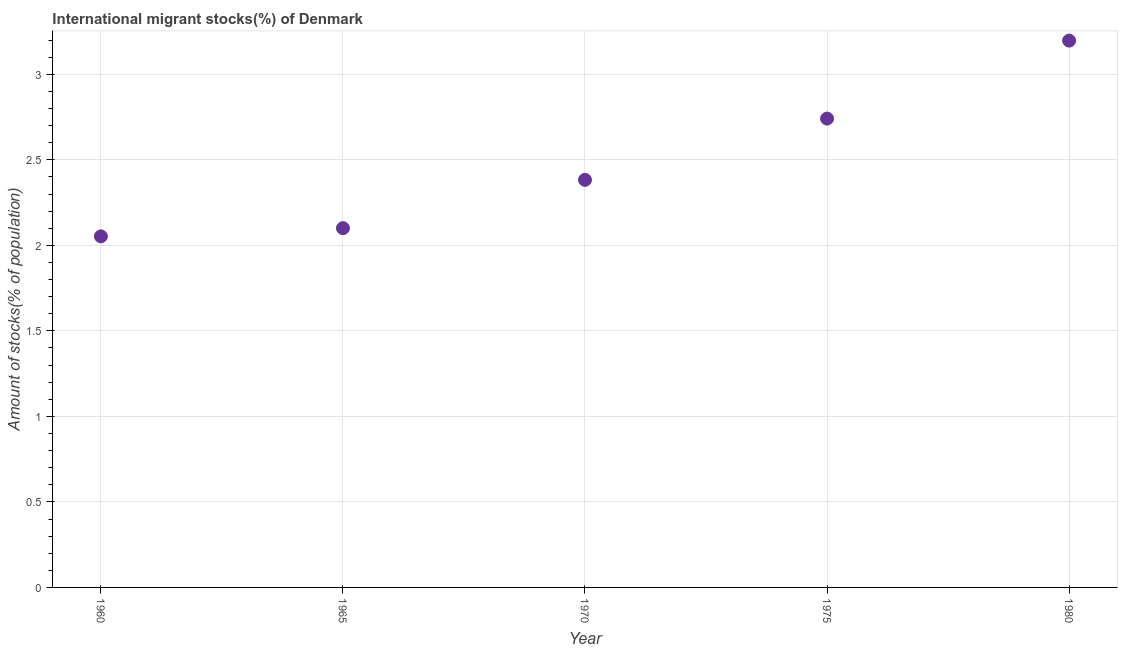What is the number of international migrant stocks in 1975?
Provide a succinct answer. 2.74. Across all years, what is the maximum number of international migrant stocks?
Offer a very short reply. 3.2. Across all years, what is the minimum number of international migrant stocks?
Your answer should be very brief. 2.05. In which year was the number of international migrant stocks maximum?
Your response must be concise. 1980. What is the sum of the number of international migrant stocks?
Your answer should be compact. 12.47. What is the difference between the number of international migrant stocks in 1960 and 1965?
Provide a short and direct response. -0.05. What is the average number of international migrant stocks per year?
Provide a succinct answer. 2.49. What is the median number of international migrant stocks?
Keep it short and to the point. 2.38. In how many years, is the number of international migrant stocks greater than 2 %?
Your answer should be very brief. 5. Do a majority of the years between 1970 and 1960 (inclusive) have number of international migrant stocks greater than 1.1 %?
Make the answer very short. No. What is the ratio of the number of international migrant stocks in 1970 to that in 1975?
Offer a very short reply. 0.87. Is the number of international migrant stocks in 1965 less than that in 1975?
Make the answer very short. Yes. Is the difference between the number of international migrant stocks in 1960 and 1970 greater than the difference between any two years?
Make the answer very short. No. What is the difference between the highest and the second highest number of international migrant stocks?
Provide a succinct answer. 0.46. What is the difference between the highest and the lowest number of international migrant stocks?
Make the answer very short. 1.14. How many dotlines are there?
Offer a very short reply. 1. How many years are there in the graph?
Make the answer very short. 5. What is the difference between two consecutive major ticks on the Y-axis?
Give a very brief answer. 0.5. Does the graph contain any zero values?
Your answer should be very brief. No. What is the title of the graph?
Your answer should be very brief. International migrant stocks(%) of Denmark. What is the label or title of the X-axis?
Offer a terse response. Year. What is the label or title of the Y-axis?
Make the answer very short. Amount of stocks(% of population). What is the Amount of stocks(% of population) in 1960?
Your response must be concise. 2.05. What is the Amount of stocks(% of population) in 1965?
Your response must be concise. 2.1. What is the Amount of stocks(% of population) in 1970?
Keep it short and to the point. 2.38. What is the Amount of stocks(% of population) in 1975?
Offer a very short reply. 2.74. What is the Amount of stocks(% of population) in 1980?
Keep it short and to the point. 3.2. What is the difference between the Amount of stocks(% of population) in 1960 and 1965?
Your answer should be very brief. -0.05. What is the difference between the Amount of stocks(% of population) in 1960 and 1970?
Give a very brief answer. -0.33. What is the difference between the Amount of stocks(% of population) in 1960 and 1975?
Your response must be concise. -0.69. What is the difference between the Amount of stocks(% of population) in 1960 and 1980?
Keep it short and to the point. -1.14. What is the difference between the Amount of stocks(% of population) in 1965 and 1970?
Make the answer very short. -0.28. What is the difference between the Amount of stocks(% of population) in 1965 and 1975?
Keep it short and to the point. -0.64. What is the difference between the Amount of stocks(% of population) in 1965 and 1980?
Ensure brevity in your answer.  -1.1. What is the difference between the Amount of stocks(% of population) in 1970 and 1975?
Provide a succinct answer. -0.36. What is the difference between the Amount of stocks(% of population) in 1970 and 1980?
Ensure brevity in your answer.  -0.81. What is the difference between the Amount of stocks(% of population) in 1975 and 1980?
Give a very brief answer. -0.46. What is the ratio of the Amount of stocks(% of population) in 1960 to that in 1965?
Ensure brevity in your answer.  0.98. What is the ratio of the Amount of stocks(% of population) in 1960 to that in 1970?
Provide a succinct answer. 0.86. What is the ratio of the Amount of stocks(% of population) in 1960 to that in 1975?
Make the answer very short. 0.75. What is the ratio of the Amount of stocks(% of population) in 1960 to that in 1980?
Your answer should be compact. 0.64. What is the ratio of the Amount of stocks(% of population) in 1965 to that in 1970?
Offer a terse response. 0.88. What is the ratio of the Amount of stocks(% of population) in 1965 to that in 1975?
Offer a terse response. 0.77. What is the ratio of the Amount of stocks(% of population) in 1965 to that in 1980?
Keep it short and to the point. 0.66. What is the ratio of the Amount of stocks(% of population) in 1970 to that in 1975?
Offer a very short reply. 0.87. What is the ratio of the Amount of stocks(% of population) in 1970 to that in 1980?
Provide a succinct answer. 0.74. What is the ratio of the Amount of stocks(% of population) in 1975 to that in 1980?
Give a very brief answer. 0.86. 